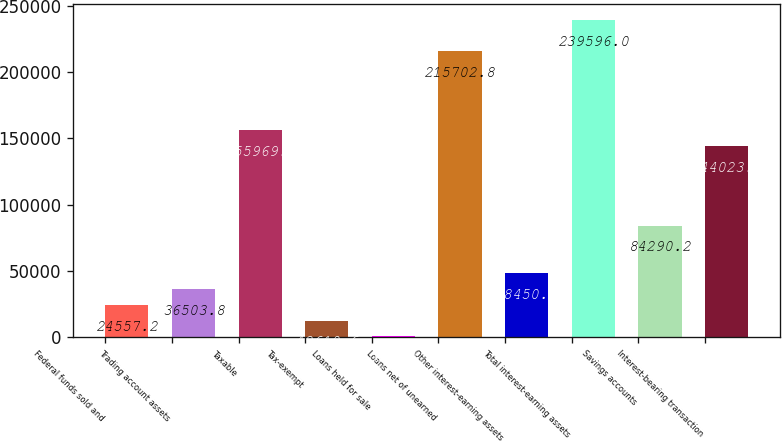Convert chart. <chart><loc_0><loc_0><loc_500><loc_500><bar_chart><fcel>Federal funds sold and<fcel>Trading account assets<fcel>Taxable<fcel>Tax-exempt<fcel>Loans held for sale<fcel>Loans net of unearned<fcel>Other interest-earning assets<fcel>Total interest-earning assets<fcel>Savings accounts<fcel>Interest-bearing transaction<nl><fcel>24557.2<fcel>36503.8<fcel>155970<fcel>12610.6<fcel>664<fcel>215703<fcel>48450.4<fcel>239596<fcel>84290.2<fcel>144023<nl></chart> 